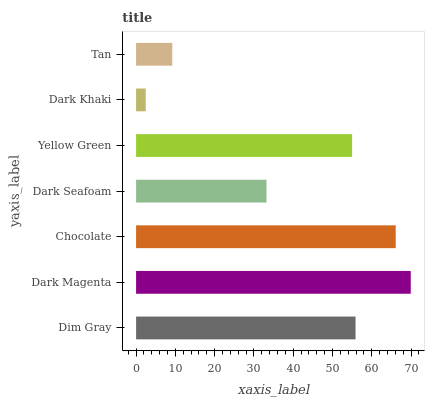Is Dark Khaki the minimum?
Answer yes or no. Yes. Is Dark Magenta the maximum?
Answer yes or no. Yes. Is Chocolate the minimum?
Answer yes or no. No. Is Chocolate the maximum?
Answer yes or no. No. Is Dark Magenta greater than Chocolate?
Answer yes or no. Yes. Is Chocolate less than Dark Magenta?
Answer yes or no. Yes. Is Chocolate greater than Dark Magenta?
Answer yes or no. No. Is Dark Magenta less than Chocolate?
Answer yes or no. No. Is Yellow Green the high median?
Answer yes or no. Yes. Is Yellow Green the low median?
Answer yes or no. Yes. Is Dim Gray the high median?
Answer yes or no. No. Is Dim Gray the low median?
Answer yes or no. No. 